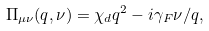Convert formula to latex. <formula><loc_0><loc_0><loc_500><loc_500>\Pi _ { \mu \nu } ( { q } , \nu ) = \chi _ { d } q ^ { 2 } - i \gamma _ { F } \nu / q ,</formula> 